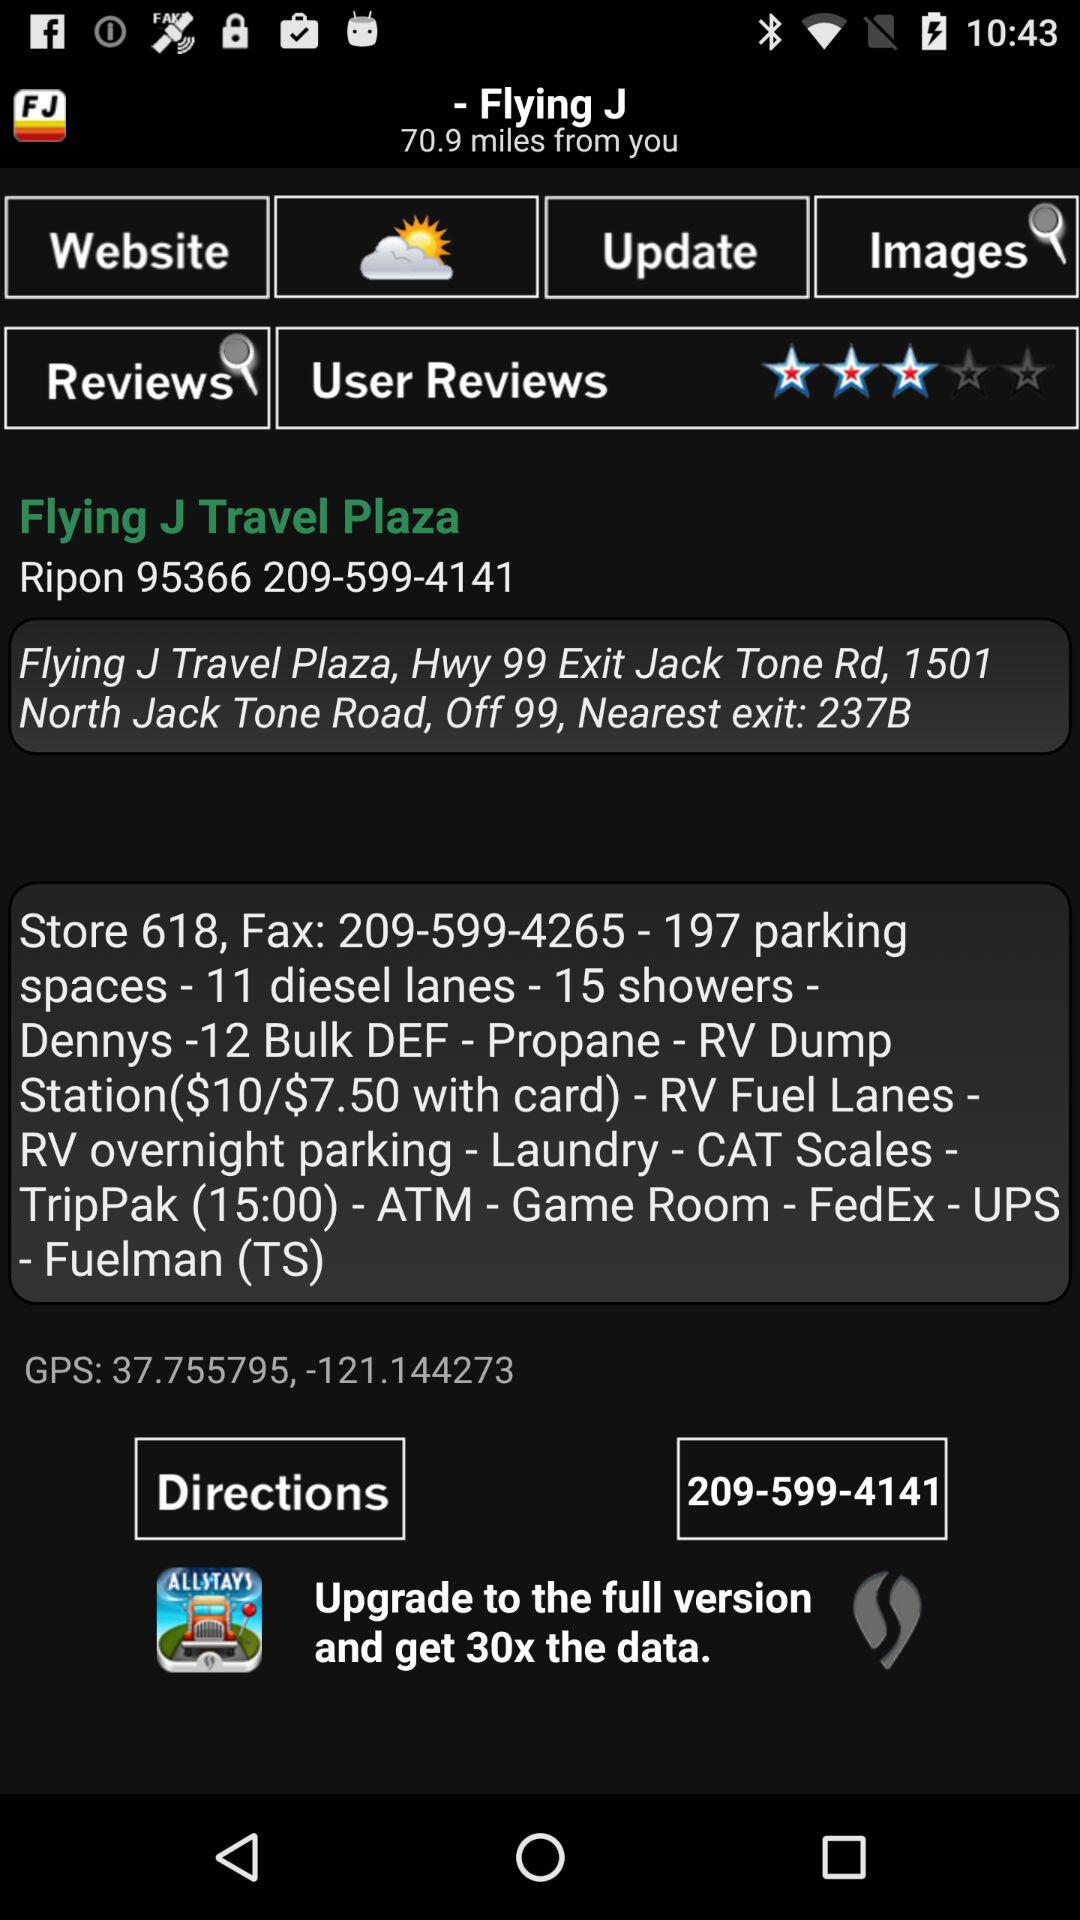How far is the "Flying J"? The "Flying J" is 70.9 miles away. 